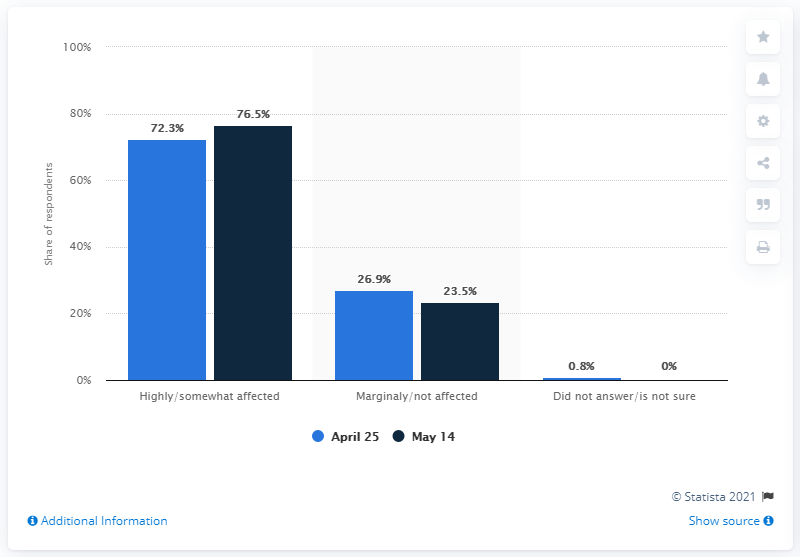Give some essential details in this illustration. According to a survey conducted in Mexico, a majority of respondents, or 74.4%, believe that the COVID-19 outbreak has highly affected their personal economy as of May 14 and April 25. Seventy-six point five percent of respondents in Mexico believe that the COVID-19 outbreak has highly affected their personal economy as of May 14. 